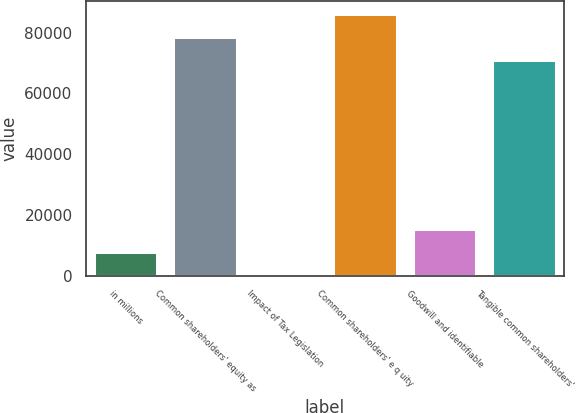Convert chart to OTSL. <chart><loc_0><loc_0><loc_500><loc_500><bar_chart><fcel>in millions<fcel>Common shareholders' equity as<fcel>Impact of Tax Legislation<fcel>Common shareholders' e q uity<fcel>Goodwill and identifiable<fcel>Tangible common shareholders'<nl><fcel>7810.1<fcel>78466.1<fcel>338<fcel>85938.2<fcel>15282.2<fcel>70994<nl></chart> 